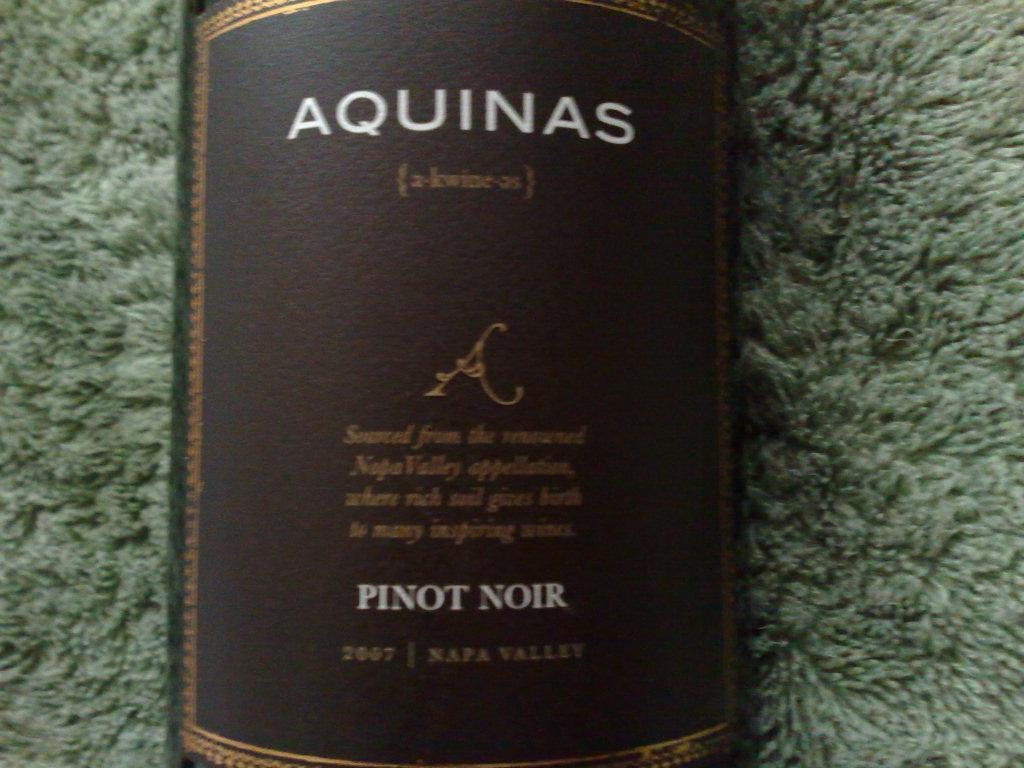<image>
Relay a brief, clear account of the picture shown. the word Aquinas that is on a bottle 